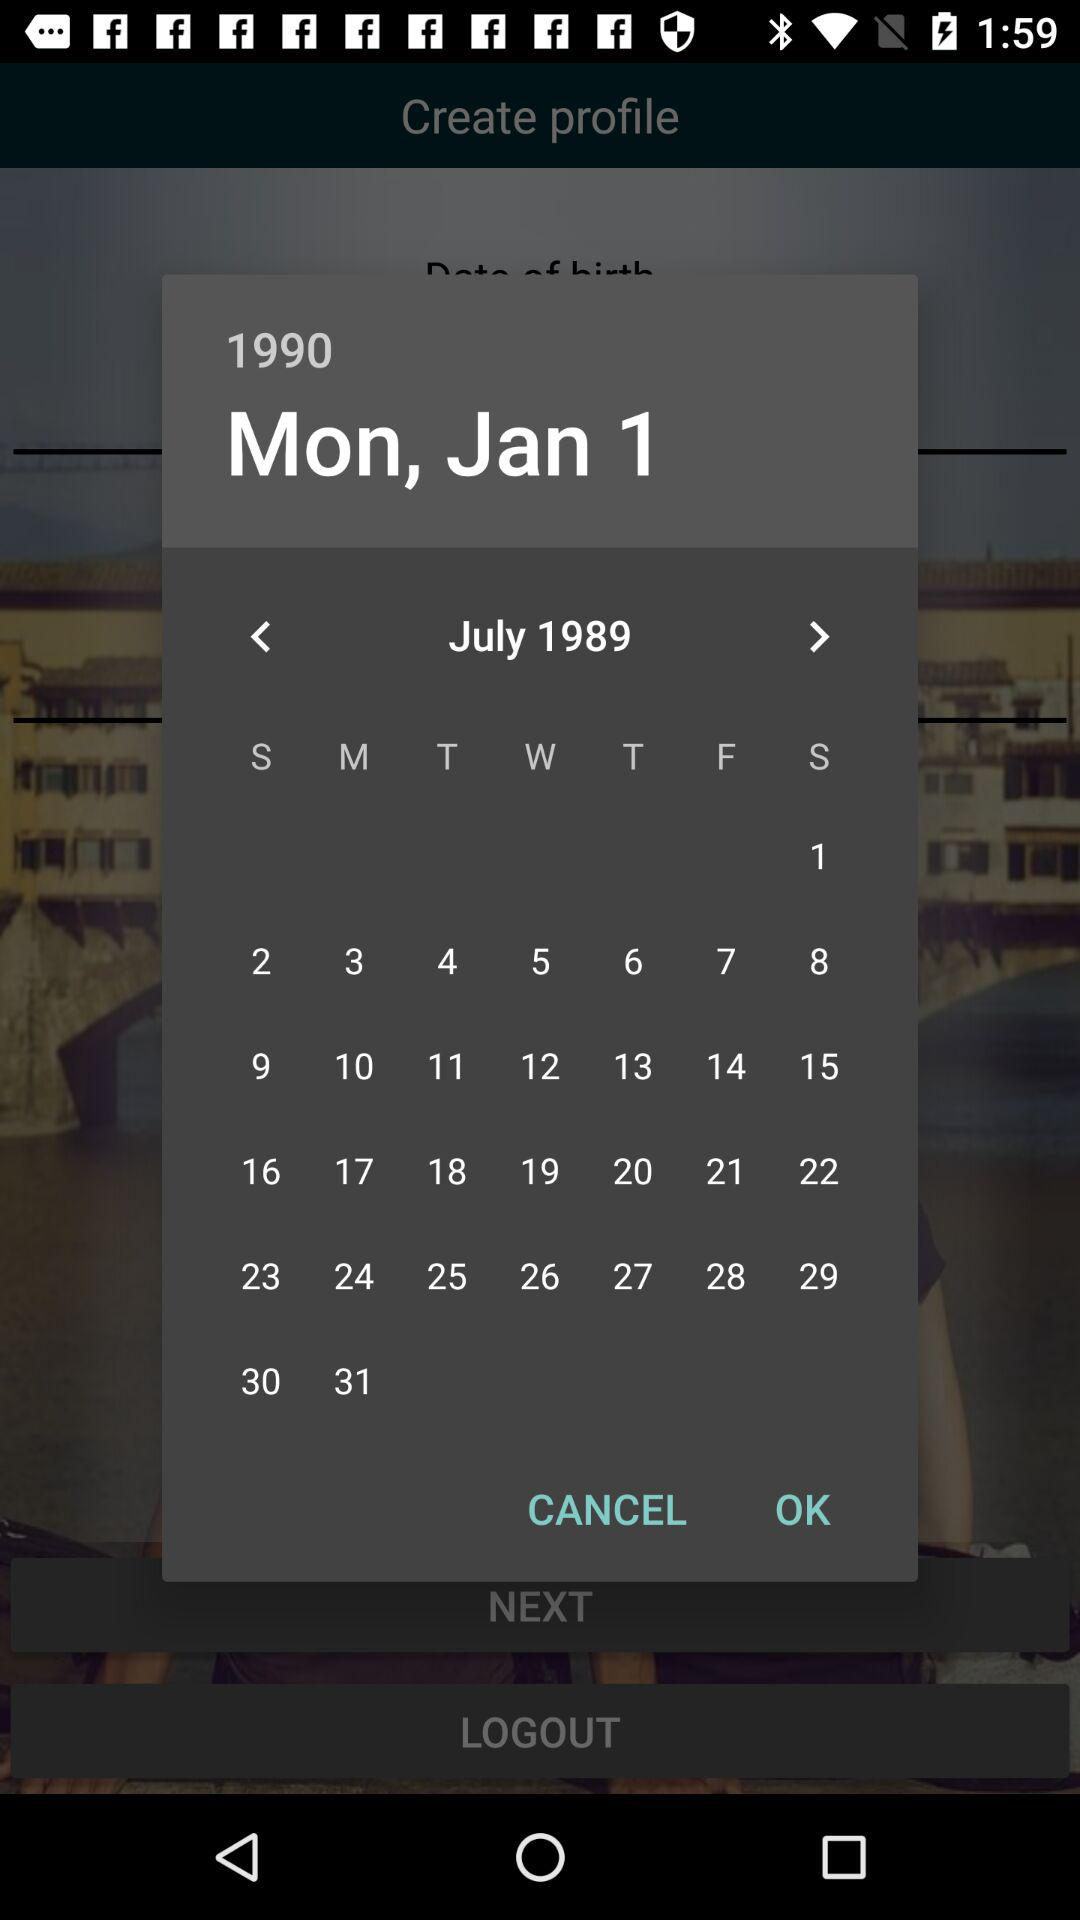Which day falls on January 1, 1990? The day is Monday. 